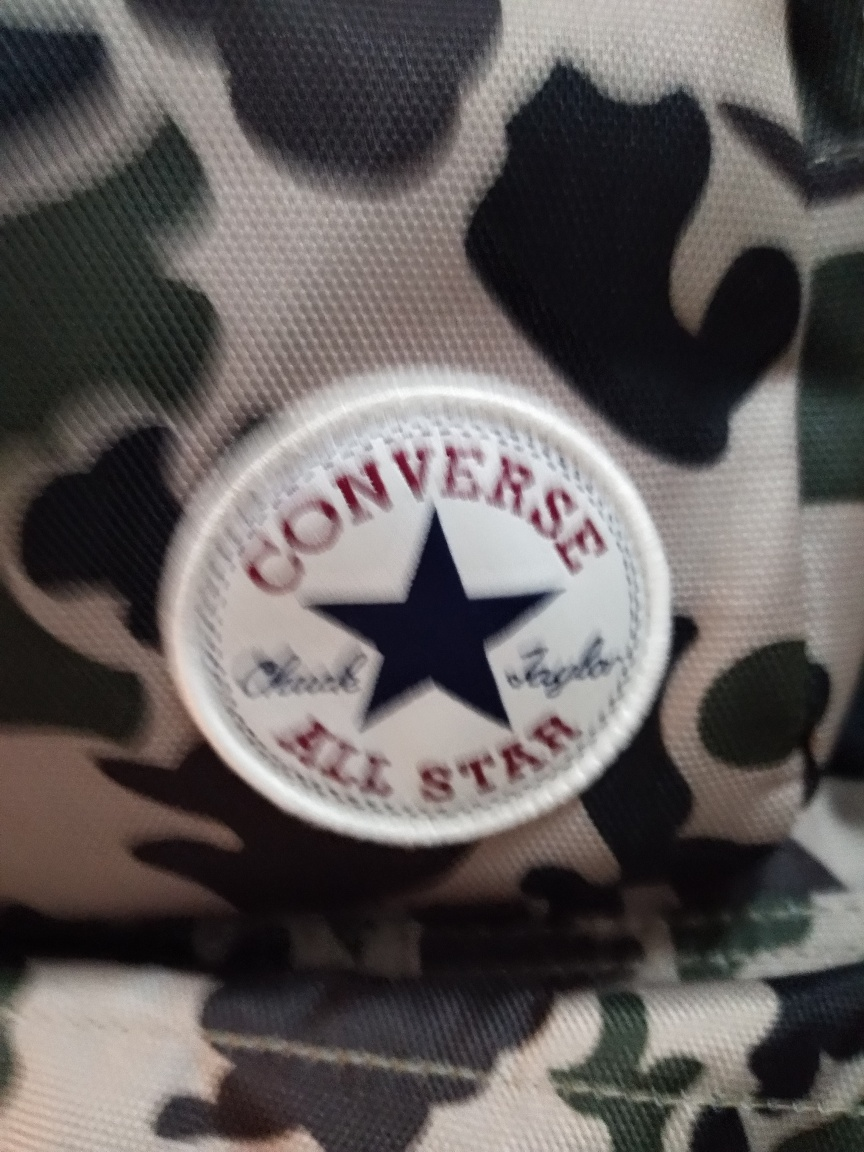What could be the potential use for this item? Given the iconic imagery, this emblem is likely attached to a piece of footwear or clothing. It might be used as a fashion statement given its classic and recognizable logo, which suggests a blend of casual style with a nod to its vintage athletic origins. What does the branding tell us about the item's quality? The brand represented in the emblem has a long-standing reputation for durable and comfortable footwear. It suggests that the item is designed to meet the expectations associated with the brand's reputation for quality. 